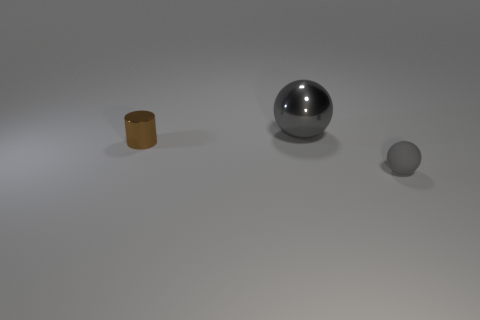Add 2 small brown metal balls. How many objects exist? 5 Subtract all cylinders. How many objects are left? 2 Subtract 0 red blocks. How many objects are left? 3 Subtract all small gray rubber spheres. Subtract all large gray metal balls. How many objects are left? 1 Add 2 small brown shiny cylinders. How many small brown shiny cylinders are left? 3 Add 2 purple metallic blocks. How many purple metallic blocks exist? 2 